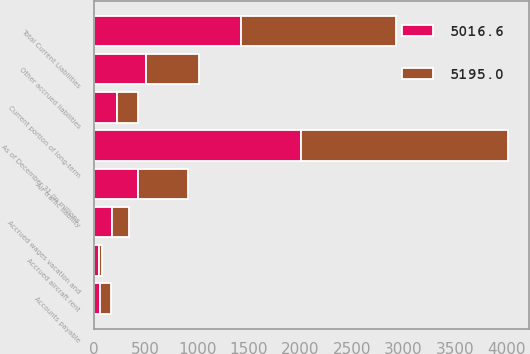Convert chart. <chart><loc_0><loc_0><loc_500><loc_500><stacked_bar_chart><ecel><fcel>As of December 31 (in millions<fcel>Accounts payable<fcel>Accrued aircraft rent<fcel>Accrued wages vacation and<fcel>Other accrued liabilities<fcel>Air traffic liability<fcel>Current portion of long-term<fcel>Total Current Liabilities<nl><fcel>5195<fcel>2011<fcel>103.6<fcel>31.6<fcel>163.8<fcel>513.3<fcel>489.4<fcel>207.9<fcel>1509.6<nl><fcel>5016.6<fcel>2010<fcel>60.2<fcel>43.1<fcel>176.6<fcel>501.2<fcel>422.4<fcel>221.2<fcel>1424.7<nl></chart> 